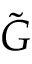<formula> <loc_0><loc_0><loc_500><loc_500>\tilde { G }</formula> 